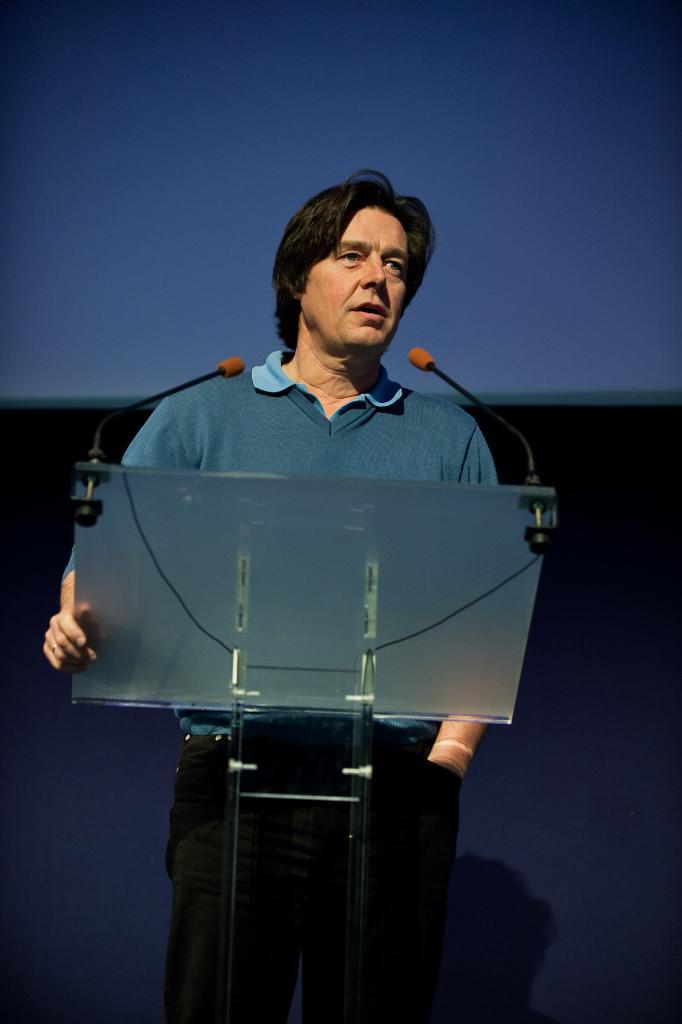What is the person near the podium doing in the image? The person is standing near a podium in the image. What is the person holding in the image? The person is holding the podium in the image. What is the person with the microphone doing in the image? The person is speaking into a microphone in the image. Can you describe the object at the top of the image? There is an object at the top of the image, but its description is not provided in the facts. How does the person increase the volume of the microphone in the image? There is no information provided about increasing the volume of the microphone in the image. What type of cloud is visible in the image? There is no mention of a cloud in the image; it only states that there is an object at the top of the image. 